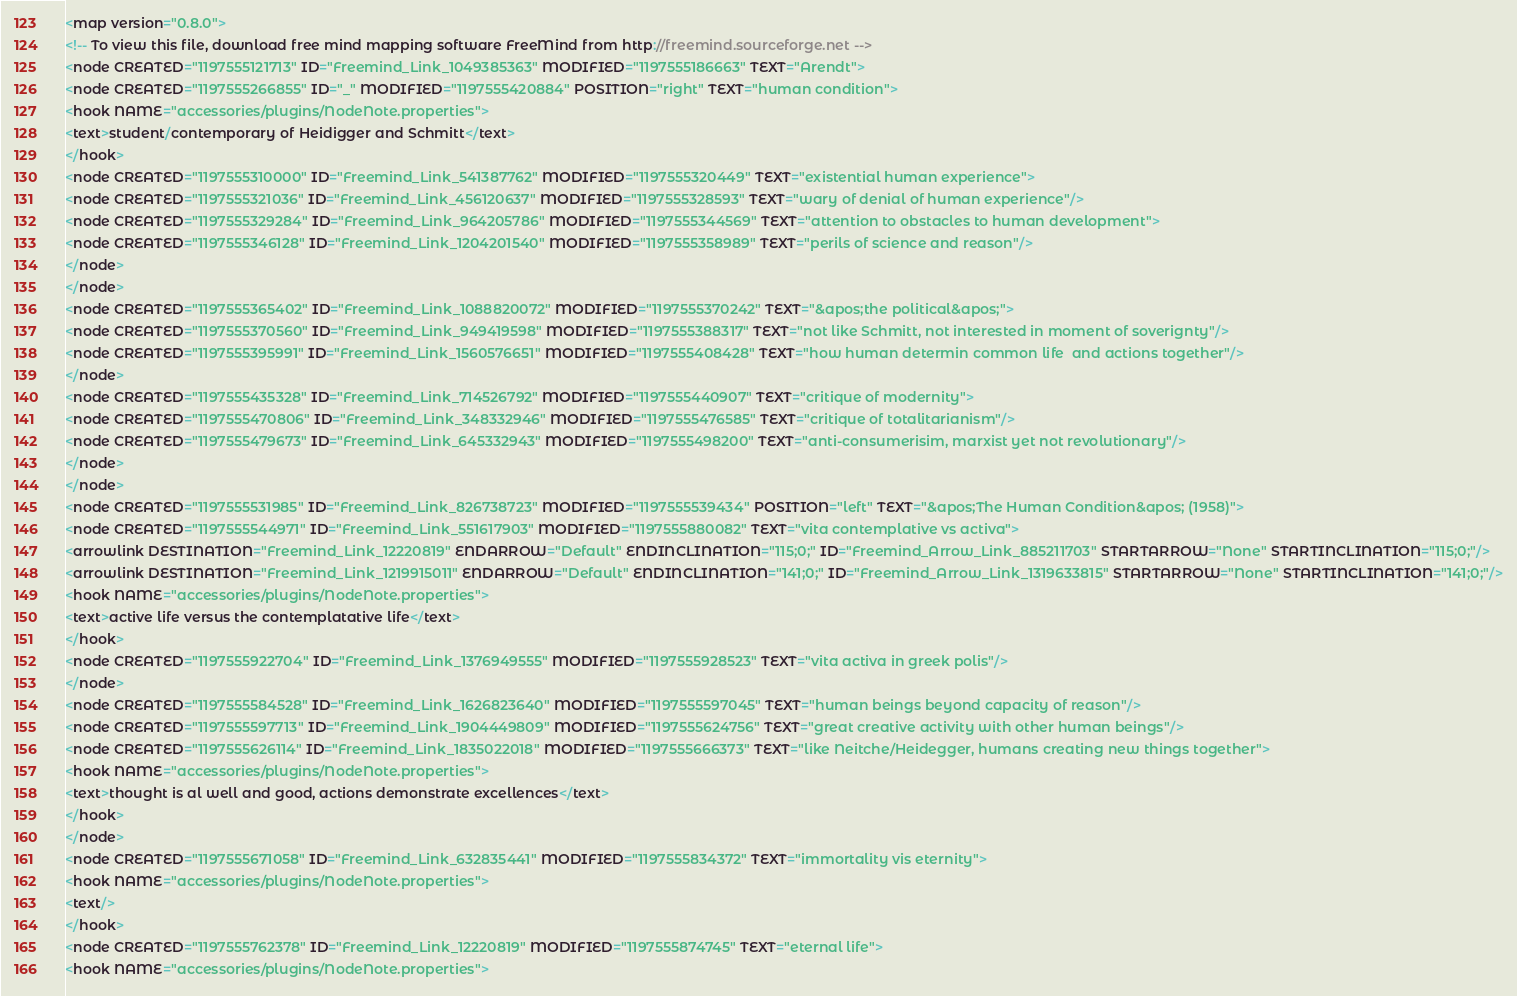Convert code to text. <code><loc_0><loc_0><loc_500><loc_500><_ObjectiveC_><map version="0.8.0">
<!-- To view this file, download free mind mapping software FreeMind from http://freemind.sourceforge.net -->
<node CREATED="1197555121713" ID="Freemind_Link_1049385363" MODIFIED="1197555186663" TEXT="Arendt">
<node CREATED="1197555266855" ID="_" MODIFIED="1197555420884" POSITION="right" TEXT="human condition">
<hook NAME="accessories/plugins/NodeNote.properties">
<text>student/contemporary of Heidigger and Schmitt</text>
</hook>
<node CREATED="1197555310000" ID="Freemind_Link_541387762" MODIFIED="1197555320449" TEXT="existential human experience">
<node CREATED="1197555321036" ID="Freemind_Link_456120637" MODIFIED="1197555328593" TEXT="wary of denial of human experience"/>
<node CREATED="1197555329284" ID="Freemind_Link_964205786" MODIFIED="1197555344569" TEXT="attention to obstacles to human development">
<node CREATED="1197555346128" ID="Freemind_Link_1204201540" MODIFIED="1197555358989" TEXT="perils of science and reason"/>
</node>
</node>
<node CREATED="1197555365402" ID="Freemind_Link_1088820072" MODIFIED="1197555370242" TEXT="&apos;the political&apos;">
<node CREATED="1197555370560" ID="Freemind_Link_949419598" MODIFIED="1197555388317" TEXT="not like Schmitt, not interested in moment of soverignty"/>
<node CREATED="1197555395991" ID="Freemind_Link_1560576651" MODIFIED="1197555408428" TEXT="how human determin common life  and actions together"/>
</node>
<node CREATED="1197555435328" ID="Freemind_Link_714526792" MODIFIED="1197555440907" TEXT="critique of modernity">
<node CREATED="1197555470806" ID="Freemind_Link_348332946" MODIFIED="1197555476585" TEXT="critique of totalitarianism"/>
<node CREATED="1197555479673" ID="Freemind_Link_645332943" MODIFIED="1197555498200" TEXT="anti-consumerisim, marxist yet not revolutionary"/>
</node>
</node>
<node CREATED="1197555531985" ID="Freemind_Link_826738723" MODIFIED="1197555539434" POSITION="left" TEXT="&apos;The Human Condition&apos; (1958)">
<node CREATED="1197555544971" ID="Freemind_Link_551617903" MODIFIED="1197555880082" TEXT="vita contemplative vs activa">
<arrowlink DESTINATION="Freemind_Link_12220819" ENDARROW="Default" ENDINCLINATION="115;0;" ID="Freemind_Arrow_Link_885211703" STARTARROW="None" STARTINCLINATION="115;0;"/>
<arrowlink DESTINATION="Freemind_Link_1219915011" ENDARROW="Default" ENDINCLINATION="141;0;" ID="Freemind_Arrow_Link_1319633815" STARTARROW="None" STARTINCLINATION="141;0;"/>
<hook NAME="accessories/plugins/NodeNote.properties">
<text>active life versus the contemplatative life</text>
</hook>
<node CREATED="1197555922704" ID="Freemind_Link_1376949555" MODIFIED="1197555928523" TEXT="vita activa in greek polis"/>
</node>
<node CREATED="1197555584528" ID="Freemind_Link_1626823640" MODIFIED="1197555597045" TEXT="human beings beyond capacity of reason"/>
<node CREATED="1197555597713" ID="Freemind_Link_1904449809" MODIFIED="1197555624756" TEXT="great creative activity with other human beings"/>
<node CREATED="1197555626114" ID="Freemind_Link_1835022018" MODIFIED="1197555666373" TEXT="like Neitche/Heidegger, humans creating new things together">
<hook NAME="accessories/plugins/NodeNote.properties">
<text>thought is al well and good, actions demonstrate excellences</text>
</hook>
</node>
<node CREATED="1197555671058" ID="Freemind_Link_632835441" MODIFIED="1197555834372" TEXT="immortality vis eternity">
<hook NAME="accessories/plugins/NodeNote.properties">
<text/>
</hook>
<node CREATED="1197555762378" ID="Freemind_Link_12220819" MODIFIED="1197555874745" TEXT="eternal life">
<hook NAME="accessories/plugins/NodeNote.properties"></code> 